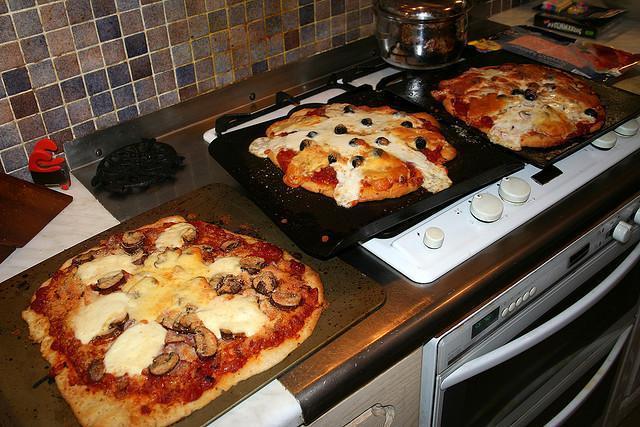How many pizzas are on the stove?
Give a very brief answer. 2. How many ovens are there?
Give a very brief answer. 1. How many pizzas are there?
Give a very brief answer. 3. How many men are in this room?
Give a very brief answer. 0. 